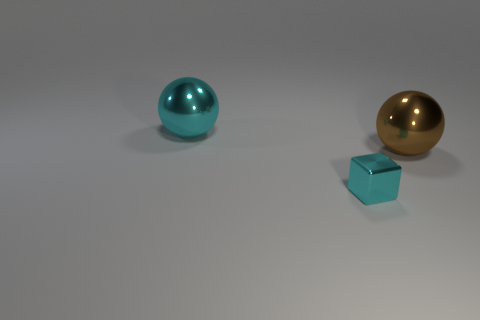Subtract all brown spheres. Subtract all gray cubes. How many spheres are left? 1 Add 1 big metal cylinders. How many objects exist? 4 Subtract all balls. How many objects are left? 1 Subtract all tiny gray metallic spheres. Subtract all large metal objects. How many objects are left? 1 Add 1 shiny things. How many shiny things are left? 4 Add 1 red objects. How many red objects exist? 1 Subtract 0 blue cylinders. How many objects are left? 3 